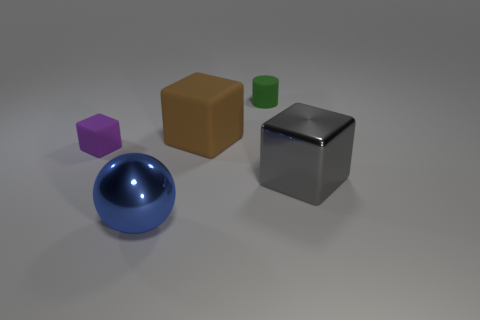Add 4 small purple rubber cubes. How many objects exist? 9 Subtract all cylinders. How many objects are left? 4 Subtract all shiny cubes. Subtract all blue balls. How many objects are left? 3 Add 2 cubes. How many cubes are left? 5 Add 1 big brown cubes. How many big brown cubes exist? 2 Subtract 0 red spheres. How many objects are left? 5 